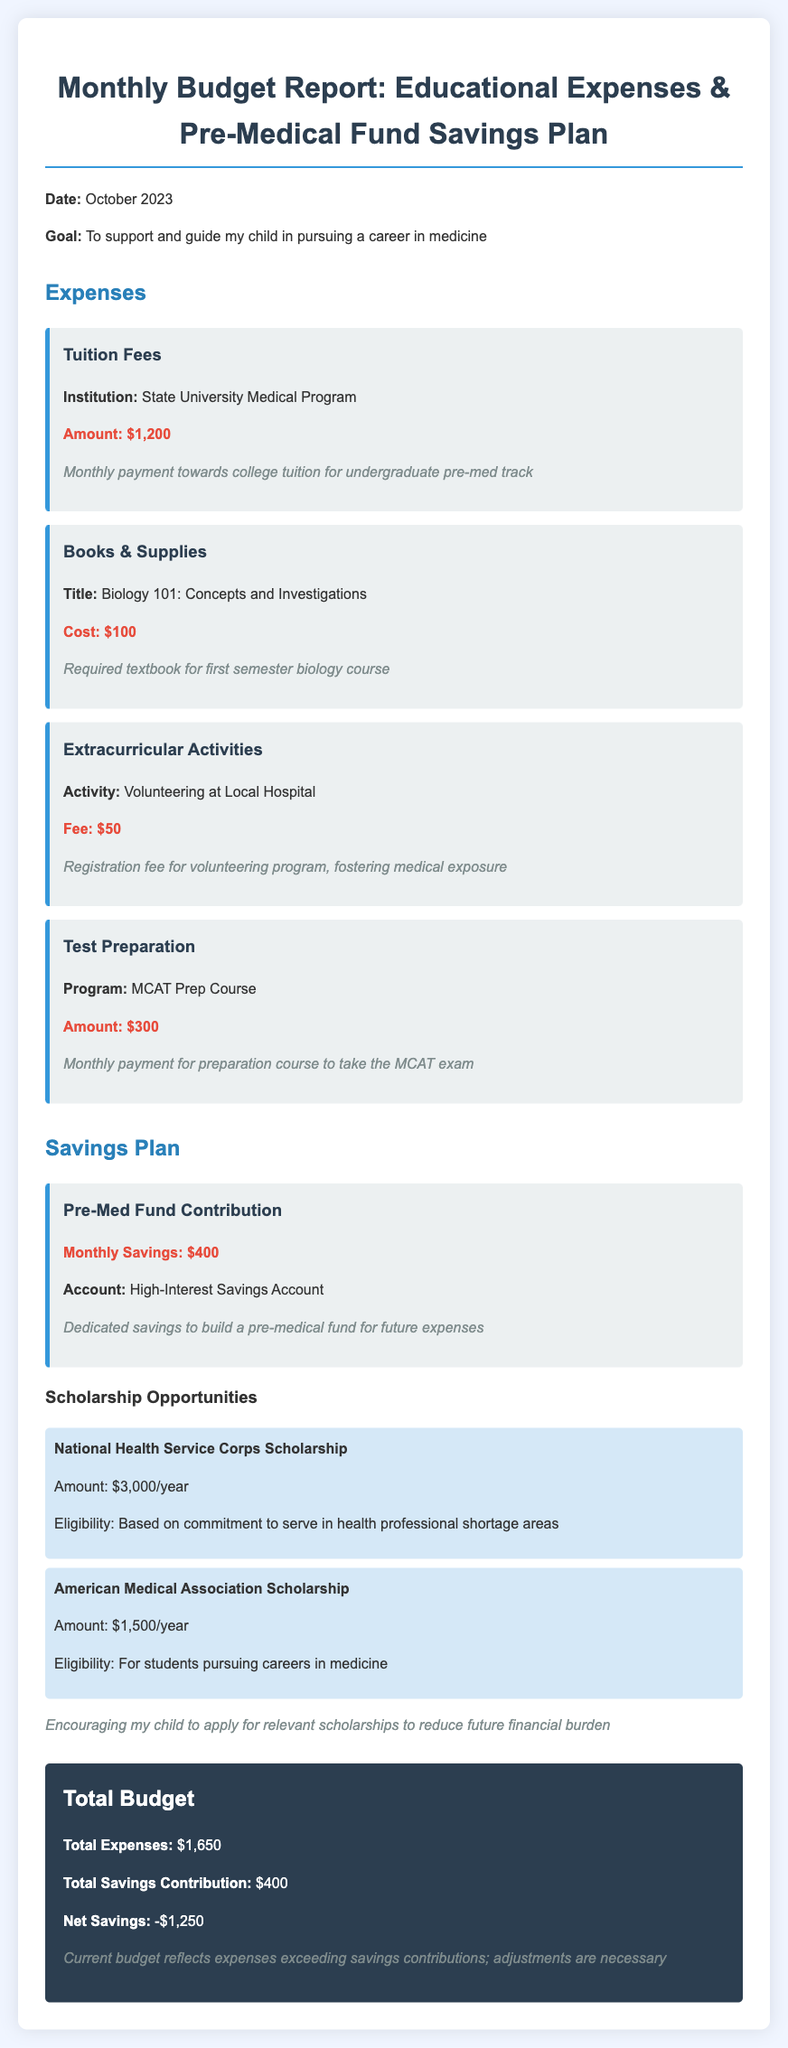What is the total amount for Tuition Fees? The amount listed for Tuition Fees in the document is $1,200.
Answer: $1,200 What is the total expense for Books & Supplies? The cost for Books & Supplies is shown as $100 for the textbook.
Answer: $100 How much is contributed monthly to the Pre-Med Fund? The document states a monthly savings contribution of $400 towards the Pre-Med Fund.
Answer: $400 What is the fee for the MCAT Prep Course? The MCAT Prep Course has a monthly payment amount of $300 as indicated in the expenses.
Answer: $300 What is the total amount of expenses? The total expenses are summed to $1,650 as listed in the document.
Answer: $1,650 How much is the National Health Service Corps Scholarship worth per year? The document lists the National Health Service Corps Scholarship as $3,000 per year.
Answer: $3,000 What is the net savings calculated in this report? The report shows net savings to be -$1,250, indicating a shortfall of expenses over savings.
Answer: -$1,250 What type of account is the Pre-Med Fund contributed to? The Pre-Med Fund contribution is made into a High-Interest Savings Account.
Answer: High-Interest Savings Account What is the goal stated in the report? The goal outlined in the report is to support and guide my child in pursuing a career in medicine.
Answer: To support and guide my child in pursuing a career in medicine 